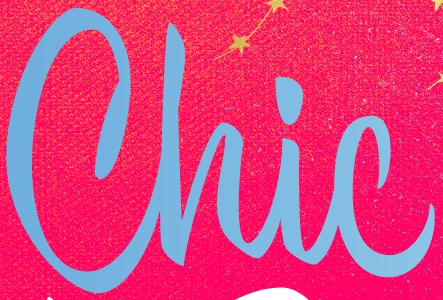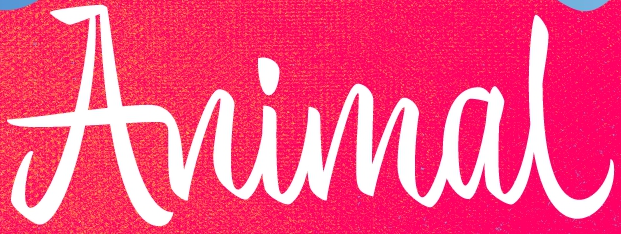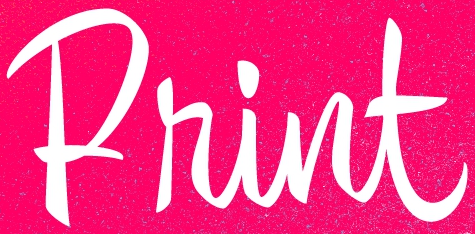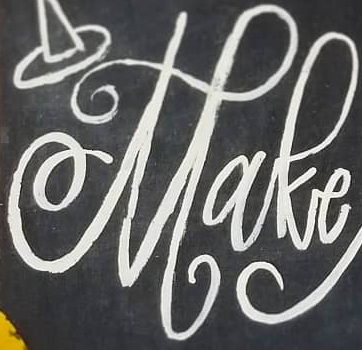What words can you see in these images in sequence, separated by a semicolon? Chic; Animal; Print; Make 